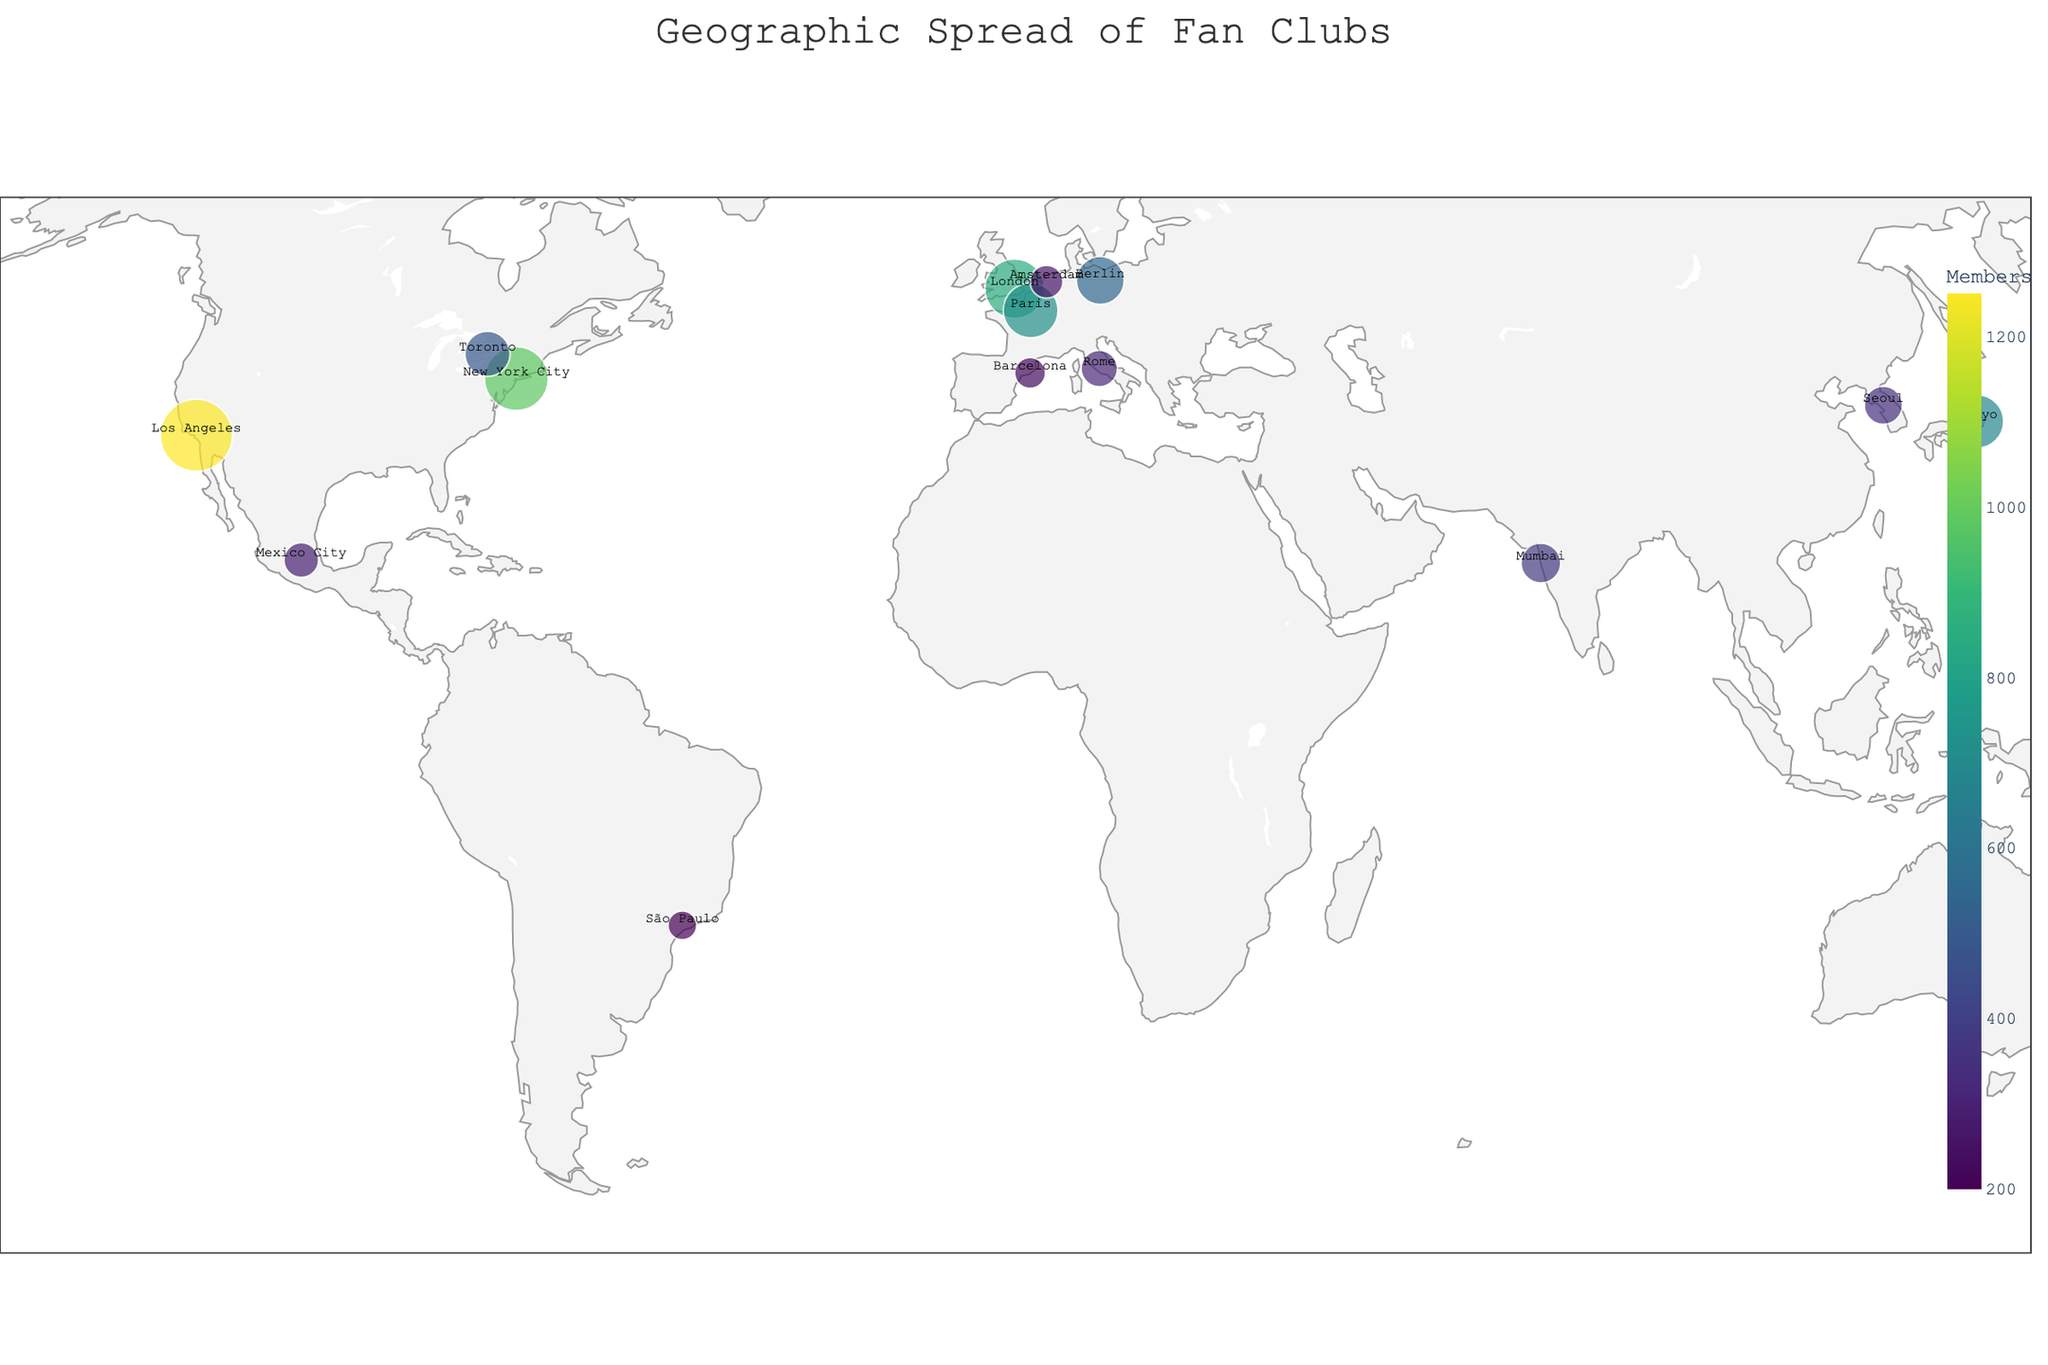What city has the largest fan club? By looking at the size of the bubbles on the map, it's clear that Los Angeles has the largest fan club since it has the largest bubble. Additionally, the hover information on the bubble confirms it.
Answer: Los Angeles Which two cities have the smallest fan clubs? From the map, we can observe the smallest bubbles and their corresponding locations. The smallest bubbles are located in São Paulo and Barcelona. The hover information confirms that they have 200 and 230 members, respectively.
Answer: São Paulo and Barcelona What is the total number of members in fan clubs across all the cities? To find the total number of members, we add the member counts of all the cities. Adding: 1250 + 980 + 850 + 720 + 680 + 550 + 490 + 430 + 380 + 350 + 320 + 290 + 260 + 230 + 200, we get a total of 8980 members.
Answer: 8980 Which region has the highest density of large fan clubs? By examining the geographic distribution and the size of the bubbles, we can see that North America, particularly the USA, has the highest density of large fan clubs with both Los Angeles and New York City having large fan clubs.
Answer: North America How many cities have more than 500 members in their fan clubs? By hovering over the bubbles or visually inspecting their sizes, we identify that the cities with more than 500 members are Los Angeles, New York City, London, Paris, Tokyo, and Berlin. Therefore, there are 6 cities in total.
Answer: 6 Which city in Europe has the most members? From the map, the largest bubble in Europe is located in London. The hover information on the bubble confirms that London has 850 members, which is the highest among the European cities displayed.
Answer: London Are there more fan club members in Tokyo or in Berlin? By comparing the size of the bubbles and the hover information over Tokyo and Berlin, we see that Tokyo has 680 members, while Berlin has 550 members. Thus, Tokyo has more members than Berlin.
Answer: Tokyo What is the average number of members in the fan clubs of all the cities? To calculate the average, divide the total number of members by the number of cities. The total is 8980 members in 15 cities. The average is 8980 / 15 which equals approximately 598.67.
Answer: 598.67 Which country has the most cities with fan clubs? By examining the geographic information on the map and the hover data, we see that the USA has the most cities listed, with both Los Angeles and New York City having active fan clubs.
Answer: USA In which continents are the fan clubs shown? By analyzing the geographic spread of the cities on the map, we can identify that the fan clubs are present in North America, South America, Europe, Asia, and Australia.
Answer: North America, South America, Europe, Asia, and Australia 